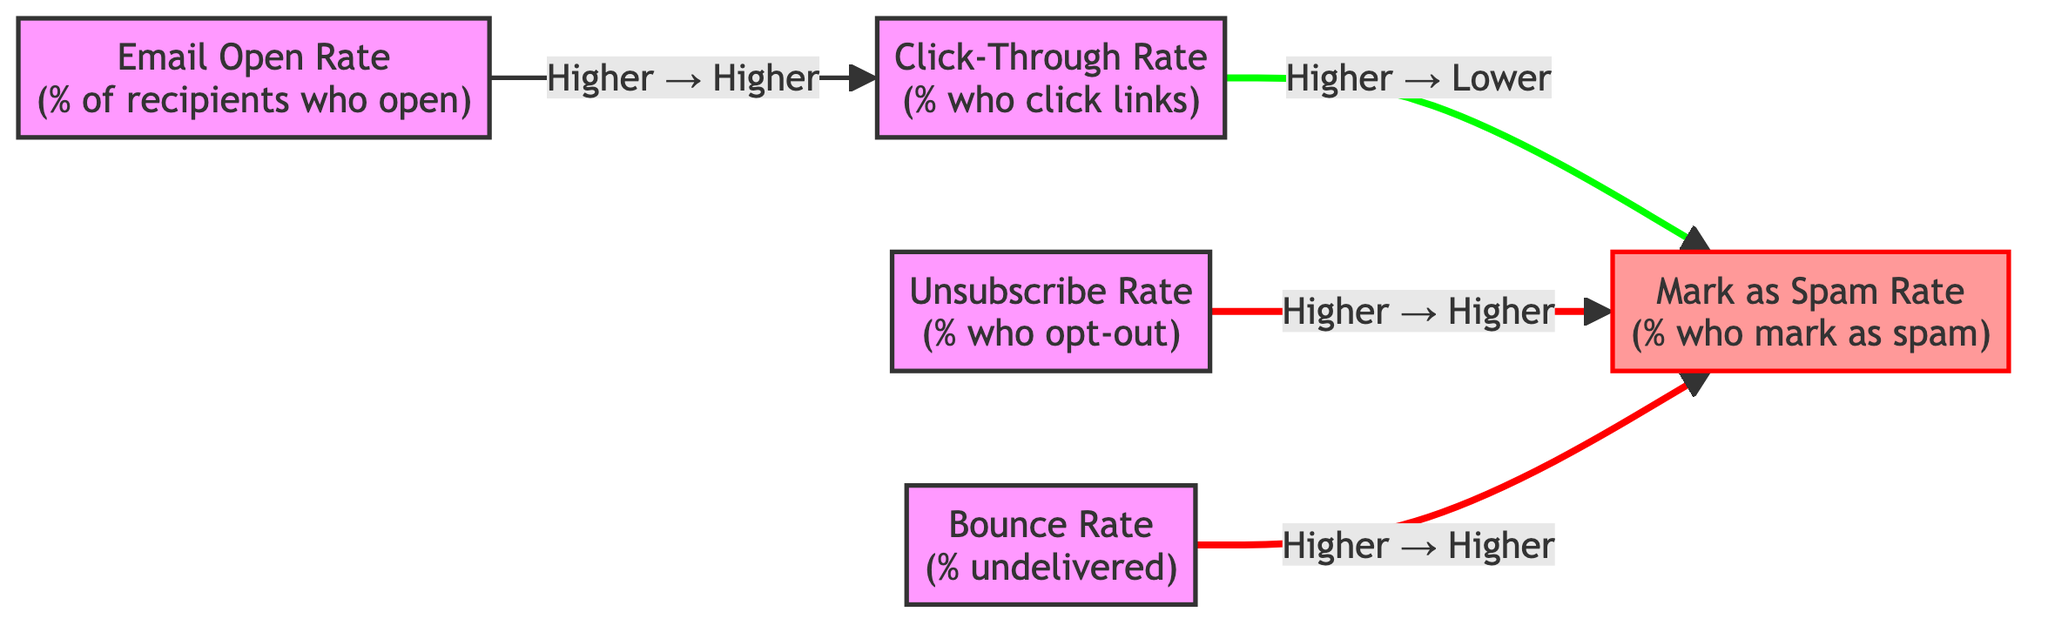What are the nodes in this diagram? The nodes in the diagram include Email Open Rate, Click-Through Rate, Unsubscribe Rate, Mark as Spam Rate, and Bounce Rate.
Answer: Email Open Rate, Click-Through Rate, Unsubscribe Rate, Mark as Spam Rate, Bounce Rate What is the relationship between Email Open Rate and Click-Through Rate? The diagram shows that a higher Email Open Rate leads to a higher Click-Through Rate, indicating a positive correlation.
Answer: Higher Open Rate → Higher CTR What is the effect of a high Unsubscribe Rate on the Mark as Spam Rate? The diagram indicates that a higher Unsubscribe Rate results in a higher Mark as Spam Rate, pointing to a negative impact on engagement.
Answer: Higher Unsubscribe Rate → Higher Mark as Spam Rate How many edges are present in the diagram? The diagram contains four edges, indicating the relationships between the nodes.
Answer: 4 If the Bounce Rate is high, what happens to the Mark as Spam Rate? According to the diagram, a higher Bounce Rate also leads to a higher Mark as Spam Rate, suggesting a connection between delivery issues and spam reporting.
Answer: Higher Bounce Rate → Higher Mark as Spam Rate What happens to Mark as Spam Rate when Click-Through Rate is high? The diagram indicates that a higher Click-Through Rate results in a lower Mark as Spam Rate, suggesting improved email quality and user engagement.
Answer: Higher CTR → Lower Mark as Spam Rate What is the primary effect of a high Email Open Rate on user engagement? The diagram shows that a high Email Open Rate has a direct effect of increasing the Click-Through Rate, which is crucial for engagement.
Answer: Higher Open Rate → Higher CTR Can you identify a node that directly influences the Mark as Spam Rate negatively? The Click-Through Rate directly influences the Mark as Spam Rate negatively, as an increase in CTR decreases the likelihood of emails being marked as spam.
Answer: ClickThroughRate If a campaign shows a high Bounce Rate, what should a marketing manager focus on improving first? A high Bounce Rate directly leads to a high Mark as Spam Rate, so the manager should focus on improving email deliverability and reducing bounces.
Answer: Improve deliverability 